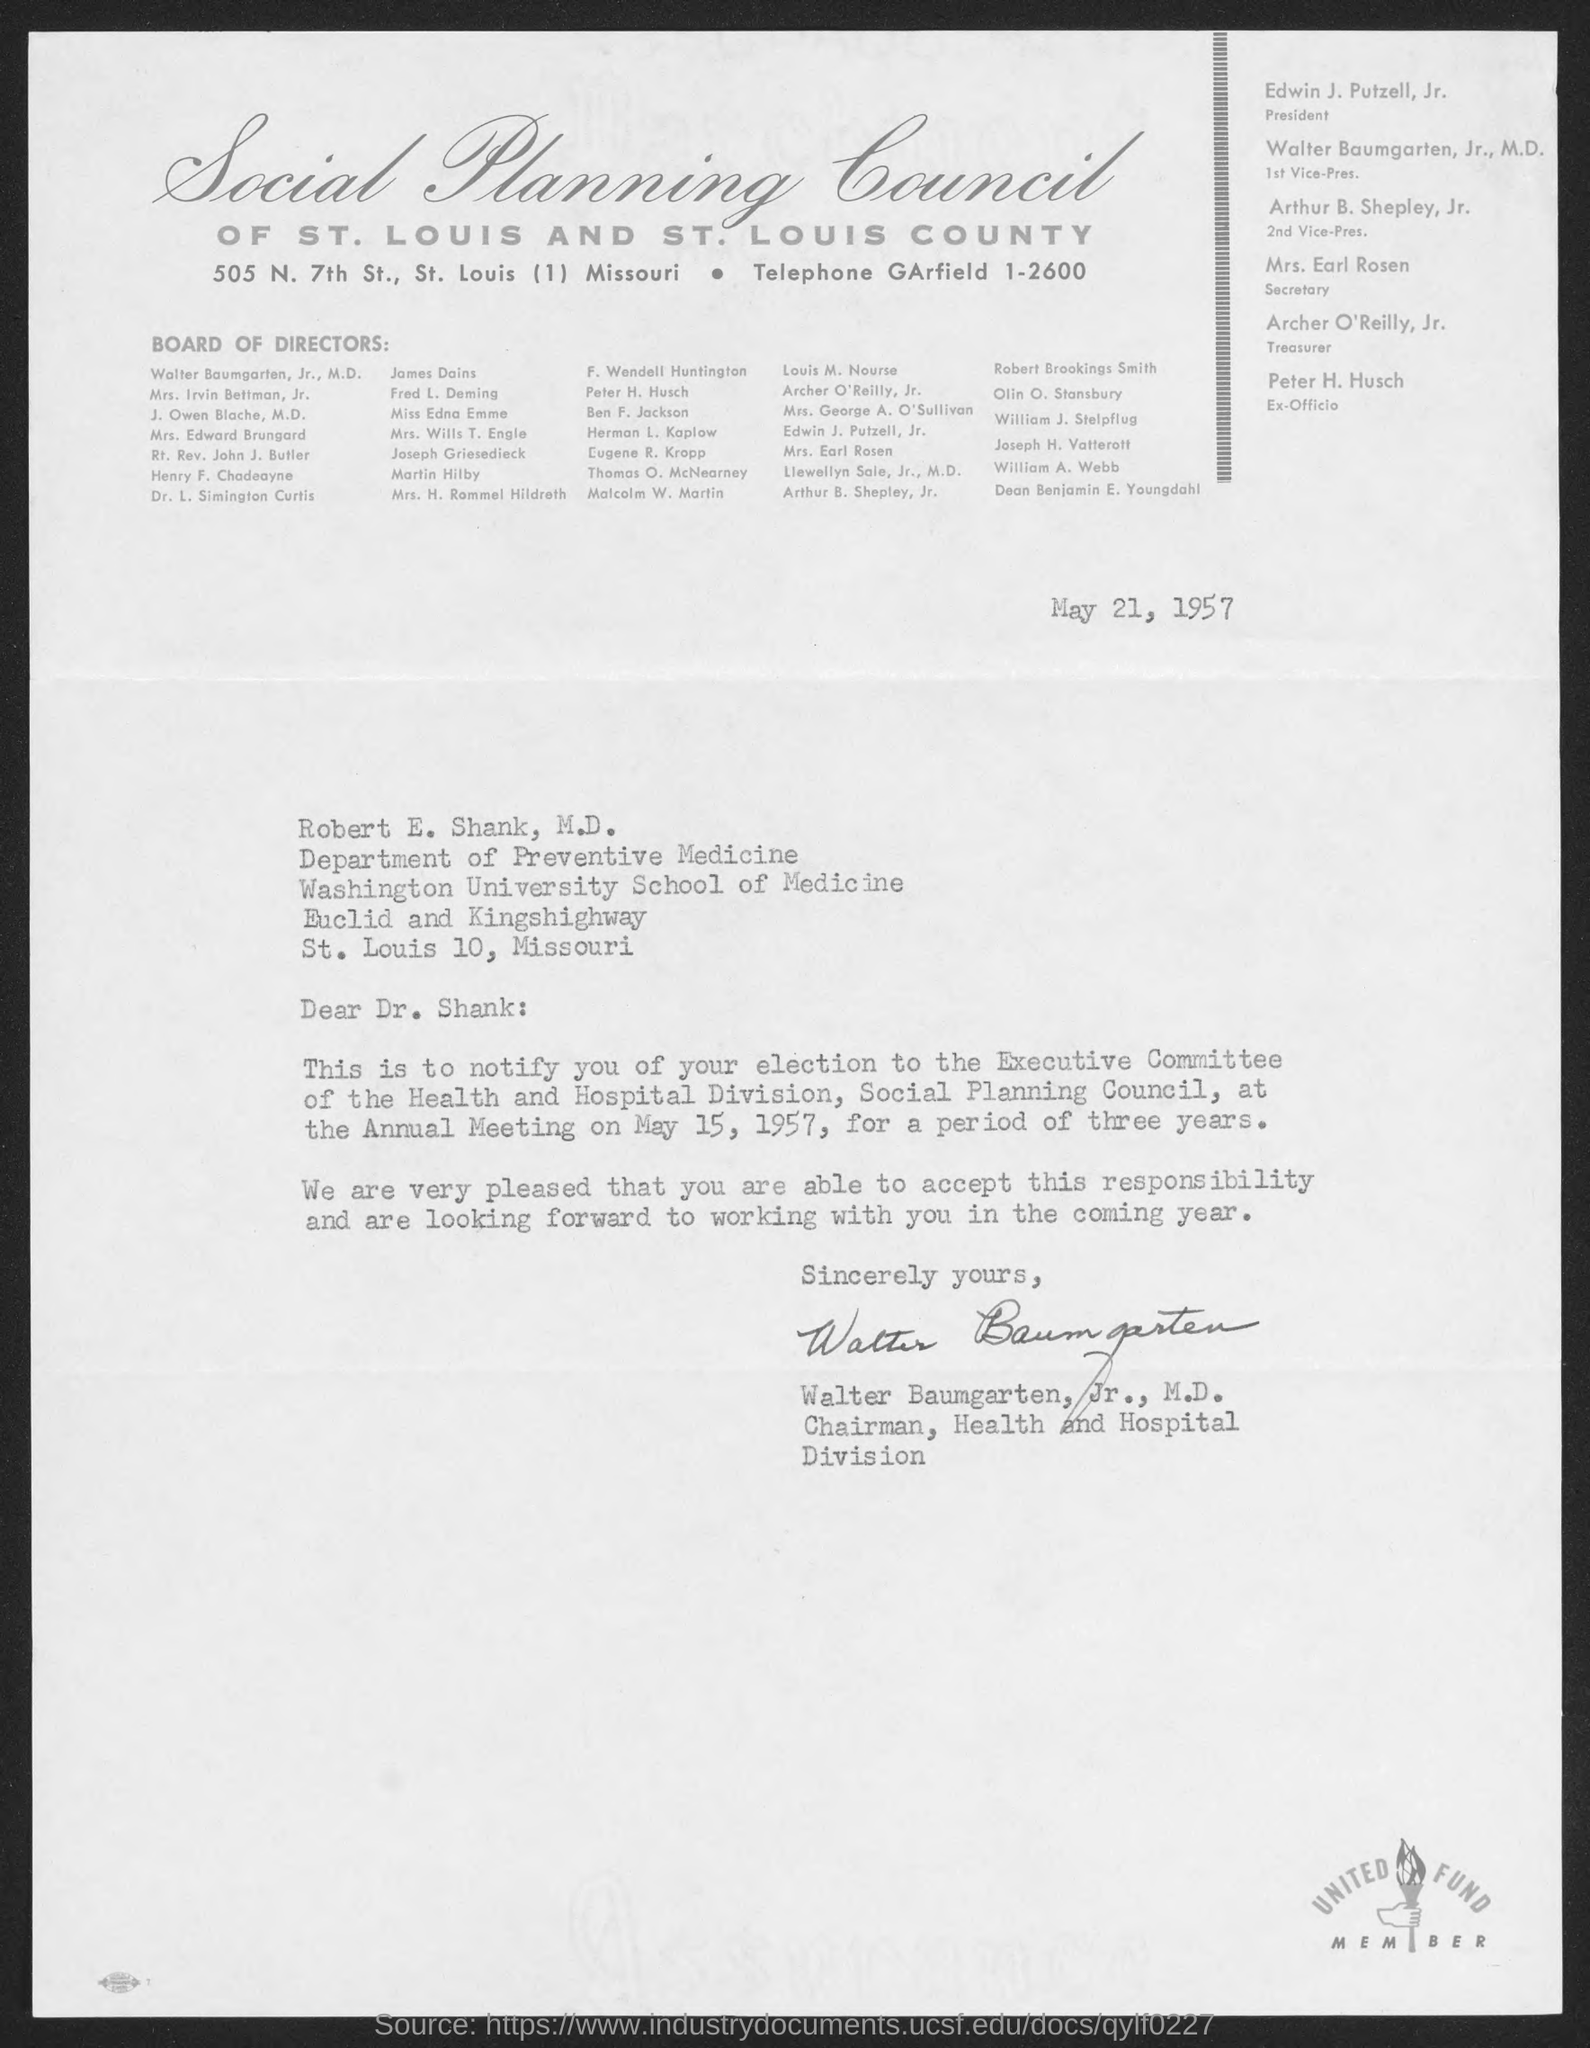Mention a couple of crucial points in this snapshot. The annual meeting is scheduled for May 15, 1957. The letter is addressed to Robert E. Shank, M.D. The date on the document is May 21, 1957. 